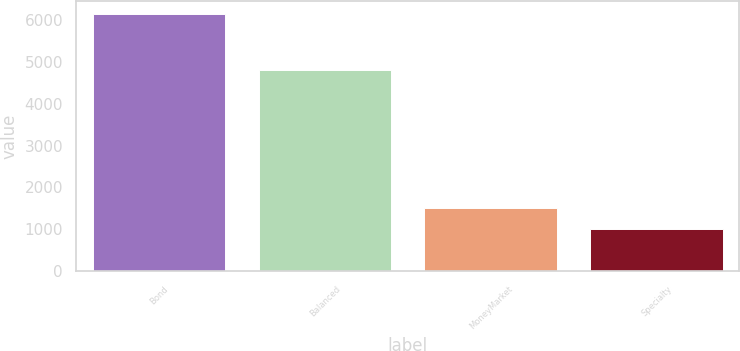Convert chart. <chart><loc_0><loc_0><loc_500><loc_500><bar_chart><fcel>Bond<fcel>Balanced<fcel>MoneyMarket<fcel>Specialty<nl><fcel>6133<fcel>4804<fcel>1516.9<fcel>1004<nl></chart> 